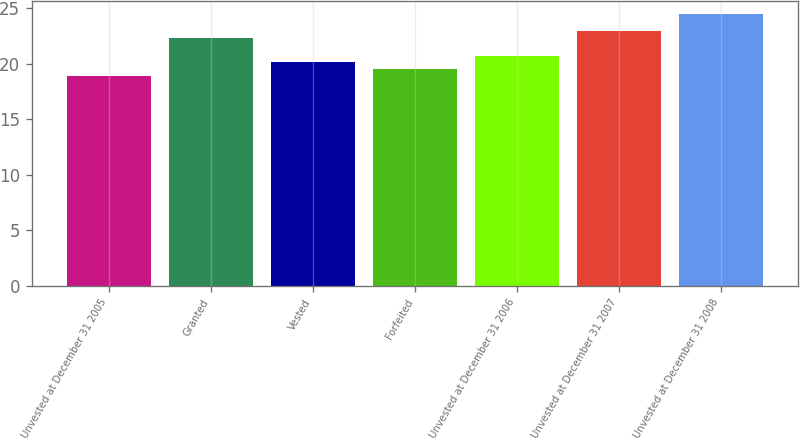Convert chart. <chart><loc_0><loc_0><loc_500><loc_500><bar_chart><fcel>Unvested at December 31 2005<fcel>Granted<fcel>Vested<fcel>Forfeited<fcel>Unvested at December 31 2006<fcel>Unvested at December 31 2007<fcel>Unvested at December 31 2008<nl><fcel>18.89<fcel>22.31<fcel>20.11<fcel>19.55<fcel>20.68<fcel>22.92<fcel>24.46<nl></chart> 